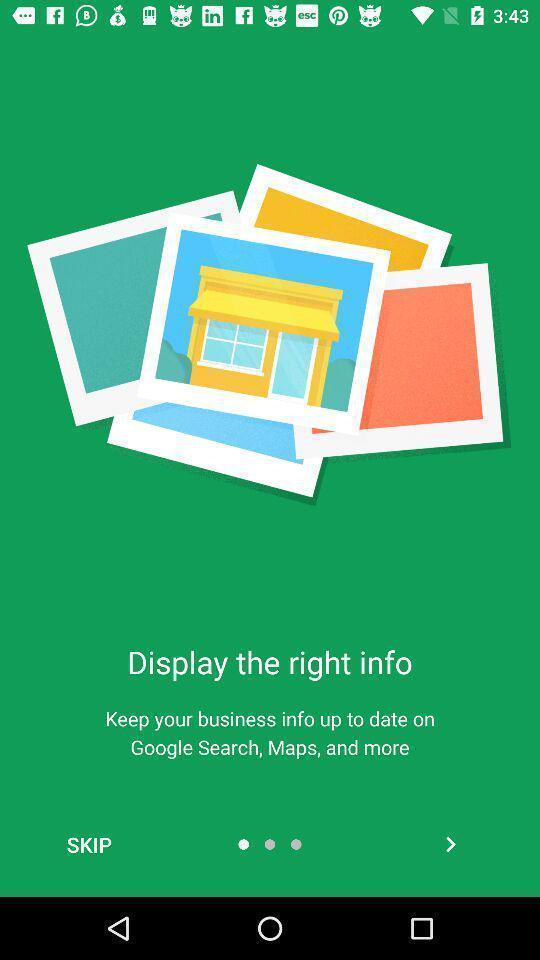Give me a narrative description of this picture. Welcome page. 